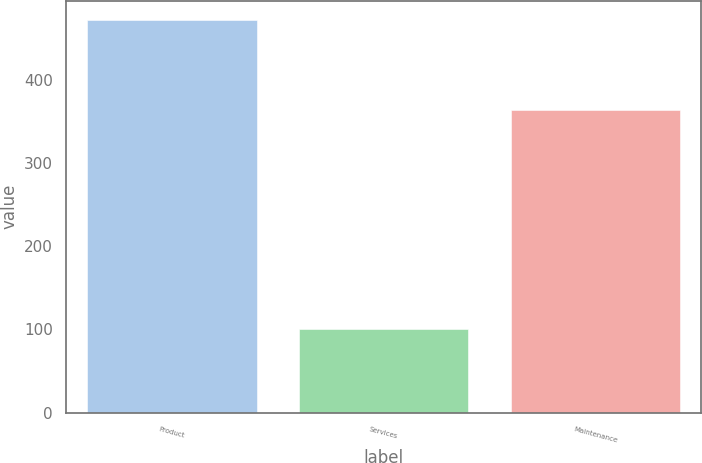Convert chart. <chart><loc_0><loc_0><loc_500><loc_500><bar_chart><fcel>Product<fcel>Services<fcel>Maintenance<nl><fcel>471.6<fcel>100.9<fcel>363.5<nl></chart> 